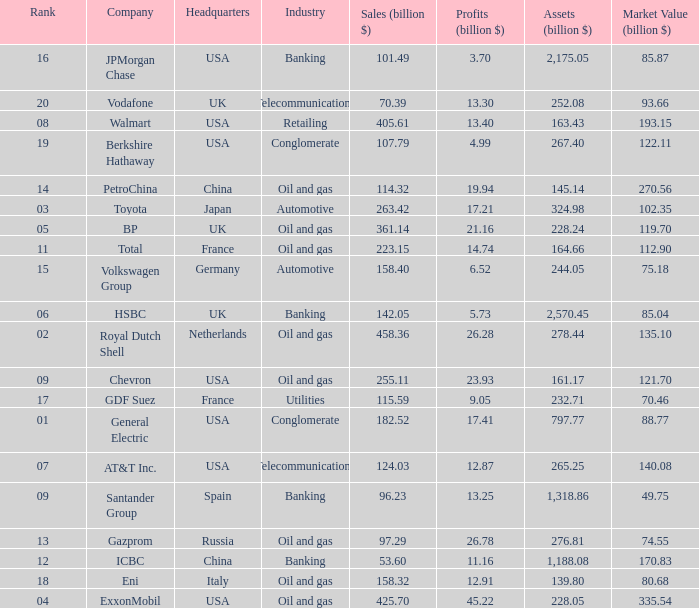Help me parse the entirety of this table. {'header': ['Rank', 'Company', 'Headquarters', 'Industry', 'Sales (billion $)', 'Profits (billion $)', 'Assets (billion $)', 'Market Value (billion $)'], 'rows': [['16', 'JPMorgan Chase', 'USA', 'Banking', '101.49', '3.70', '2,175.05', '85.87'], ['20', 'Vodafone', 'UK', 'Telecommunications', '70.39', '13.30', '252.08', '93.66'], ['08', 'Walmart', 'USA', 'Retailing', '405.61', '13.40', '163.43', '193.15'], ['19', 'Berkshire Hathaway', 'USA', 'Conglomerate', '107.79', '4.99', '267.40', '122.11'], ['14', 'PetroChina', 'China', 'Oil and gas', '114.32', '19.94', '145.14', '270.56'], ['03', 'Toyota', 'Japan', 'Automotive', '263.42', '17.21', '324.98', '102.35'], ['05', 'BP', 'UK', 'Oil and gas', '361.14', '21.16', '228.24', '119.70'], ['11', 'Total', 'France', 'Oil and gas', '223.15', '14.74', '164.66', '112.90'], ['15', 'Volkswagen Group', 'Germany', 'Automotive', '158.40', '6.52', '244.05', '75.18'], ['06', 'HSBC', 'UK', 'Banking', '142.05', '5.73', '2,570.45', '85.04'], ['02', 'Royal Dutch Shell', 'Netherlands', 'Oil and gas', '458.36', '26.28', '278.44', '135.10'], ['09', 'Chevron', 'USA', 'Oil and gas', '255.11', '23.93', '161.17', '121.70'], ['17', 'GDF Suez', 'France', 'Utilities', '115.59', '9.05', '232.71', '70.46'], ['01', 'General Electric', 'USA', 'Conglomerate', '182.52', '17.41', '797.77', '88.77'], ['07', 'AT&T Inc.', 'USA', 'Telecommunications', '124.03', '12.87', '265.25', '140.08'], ['09', 'Santander Group', 'Spain', 'Banking', '96.23', '13.25', '1,318.86', '49.75'], ['13', 'Gazprom', 'Russia', 'Oil and gas', '97.29', '26.78', '276.81', '74.55'], ['12', 'ICBC', 'China', 'Banking', '53.60', '11.16', '1,188.08', '170.83'], ['18', 'Eni', 'Italy', 'Oil and gas', '158.32', '12.91', '139.80', '80.68'], ['04', 'ExxonMobil', 'USA', 'Oil and gas', '425.70', '45.22', '228.05', '335.54']]} Name the lowest Market Value (billion $) which has Assets (billion $) larger than 276.81, and a Company of toyota, and Profits (billion $) larger than 17.21? None. 